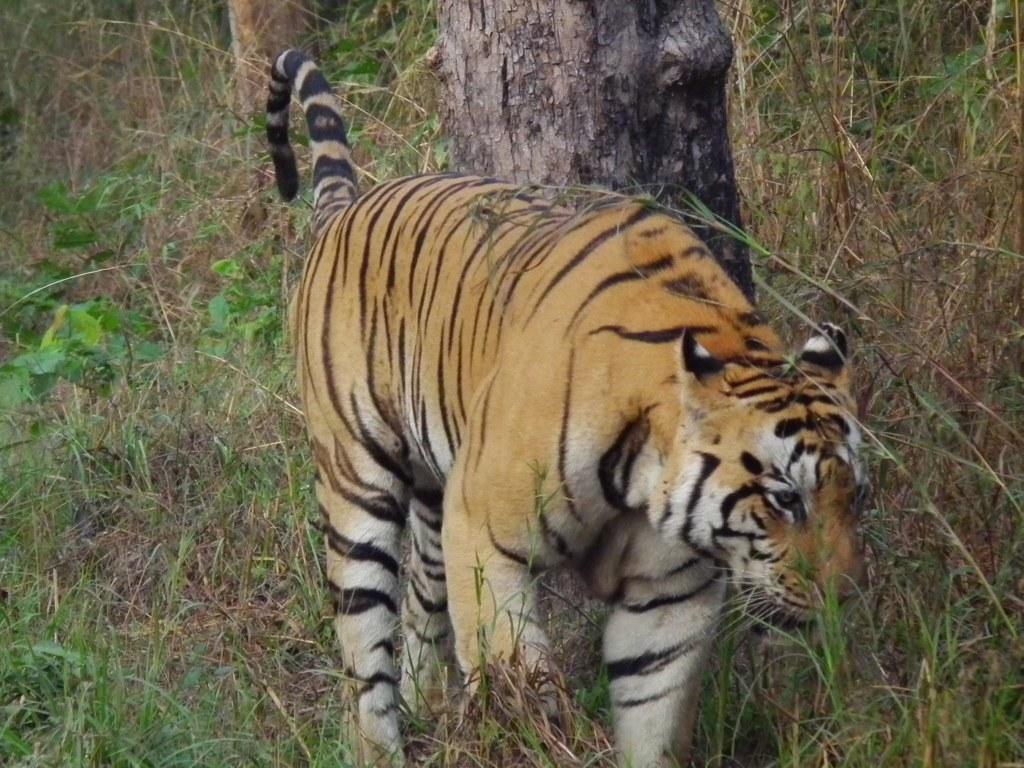How would you summarize this image in a sentence or two? In this picture I can see a lion on the grass and there are some tree trunks. 